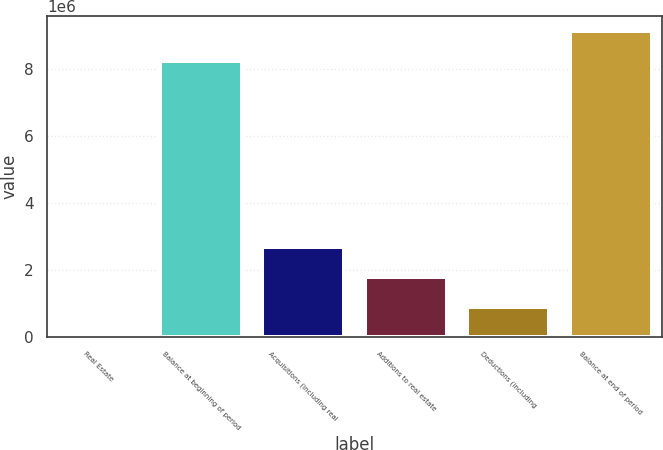<chart> <loc_0><loc_0><loc_500><loc_500><bar_chart><fcel>Real Estate<fcel>Balance at beginning of period<fcel>Acquisitions (including real<fcel>Additions to real estate<fcel>Deductions (including<fcel>Balance at end of period<nl><fcel>2015<fcel>8.22886e+06<fcel>2.68499e+06<fcel>1.79066e+06<fcel>896340<fcel>9.12318e+06<nl></chart> 